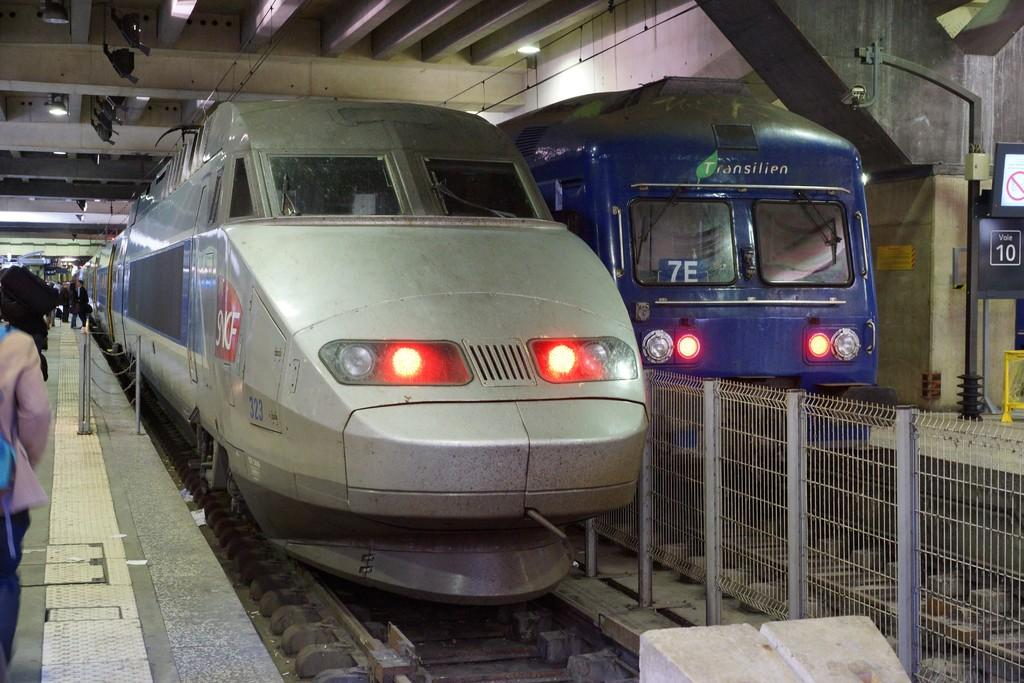Provide a one-sentence caption for the provided image. a couple trains with one that has the letters 7E on it. 